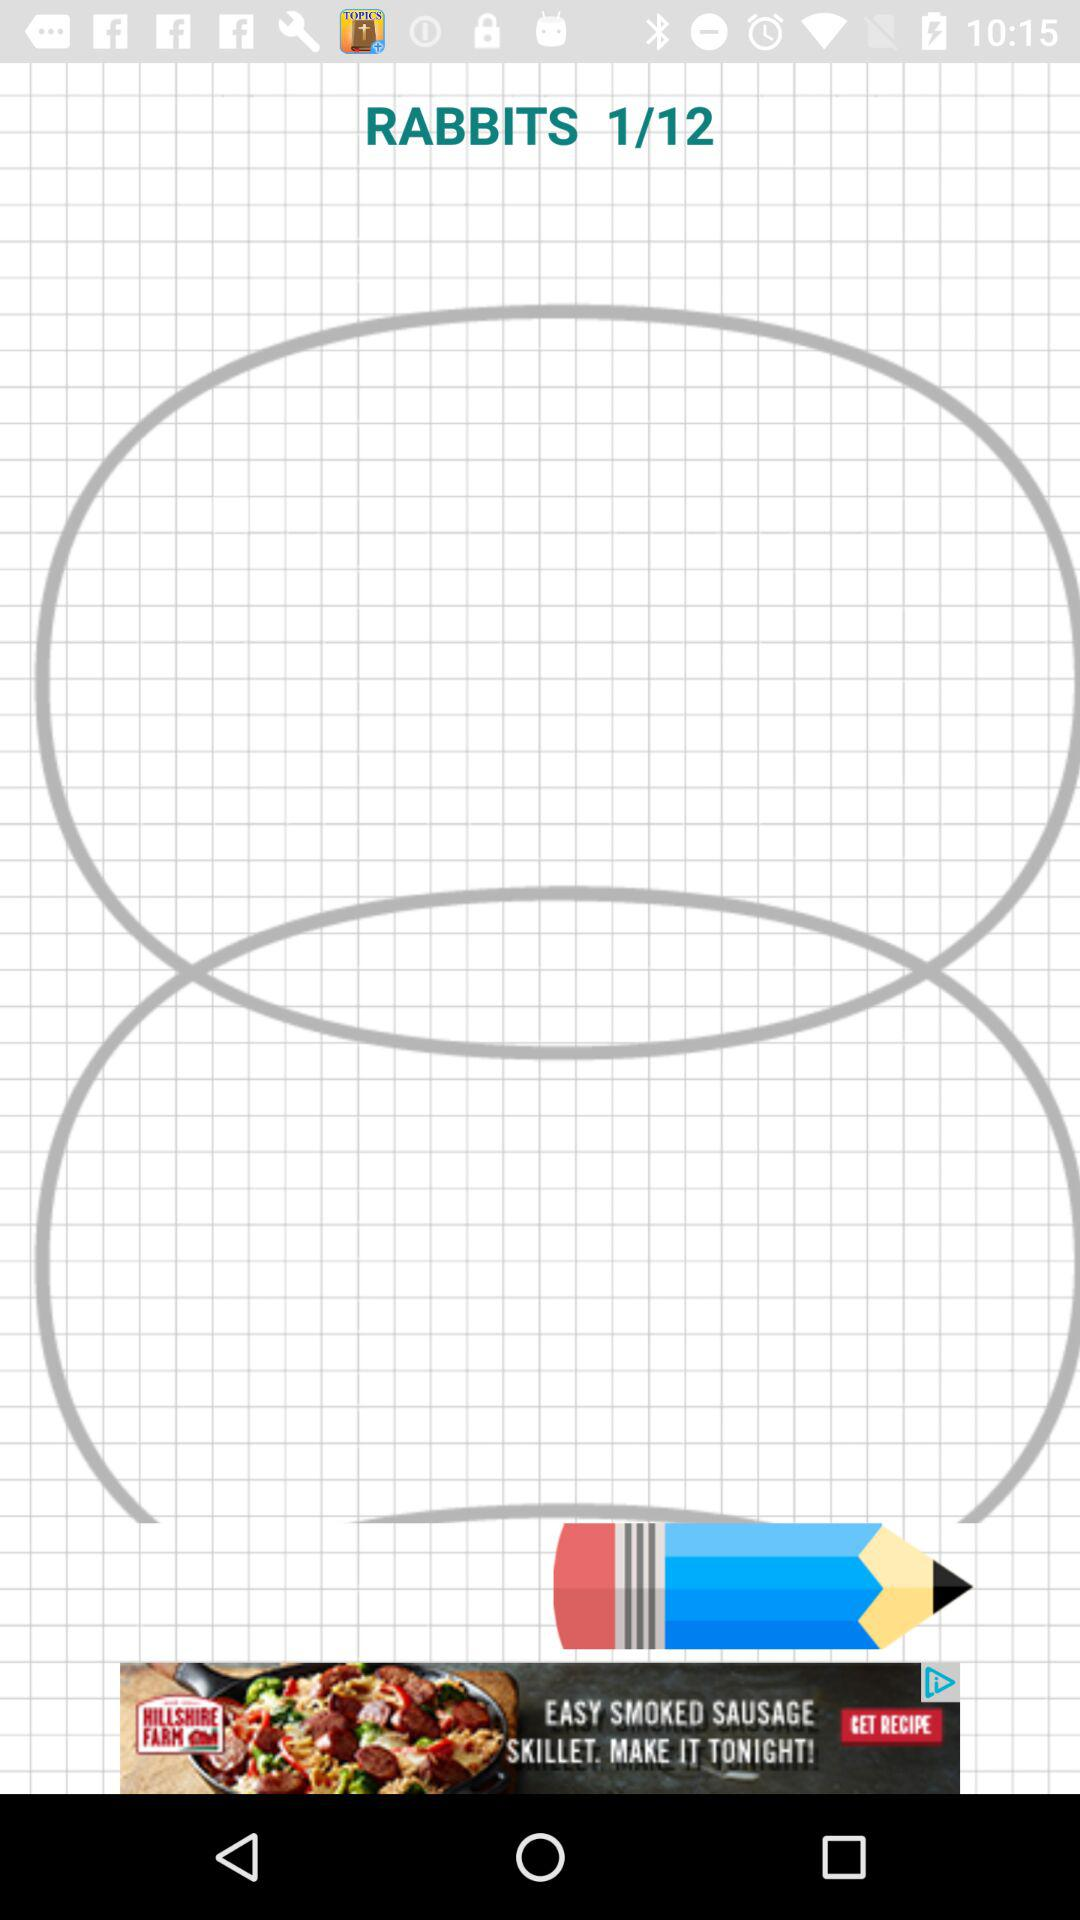How many steps are there to draw "RABBITS"? There are 12 steps. 